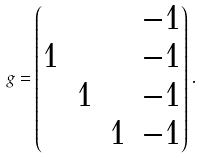<formula> <loc_0><loc_0><loc_500><loc_500>g = \begin{pmatrix} & & & - 1 \\ 1 & & & - 1 \\ & 1 & & - 1 \\ & & 1 & - 1 \end{pmatrix} .</formula> 